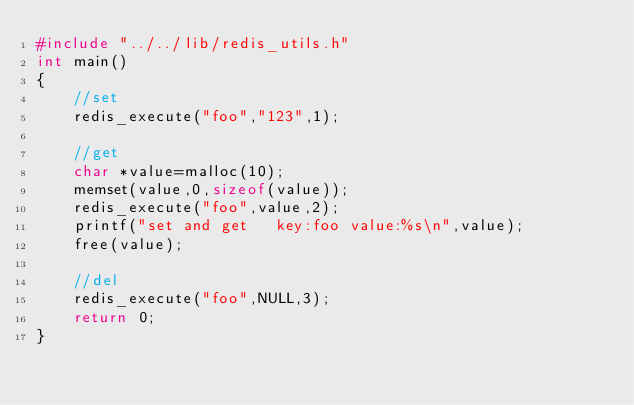<code> <loc_0><loc_0><loc_500><loc_500><_C_>#include "../../lib/redis_utils.h"  
int main()  
{  
    //set
    redis_execute("foo","123",1); 

    //get
    char *value=malloc(10);
    memset(value,0,sizeof(value));
    redis_execute("foo",value,2);
    printf("set and get   key:foo value:%s\n",value);
    free(value);
  
    //del
    redis_execute("foo",NULL,3);
    return 0;  
}</code> 